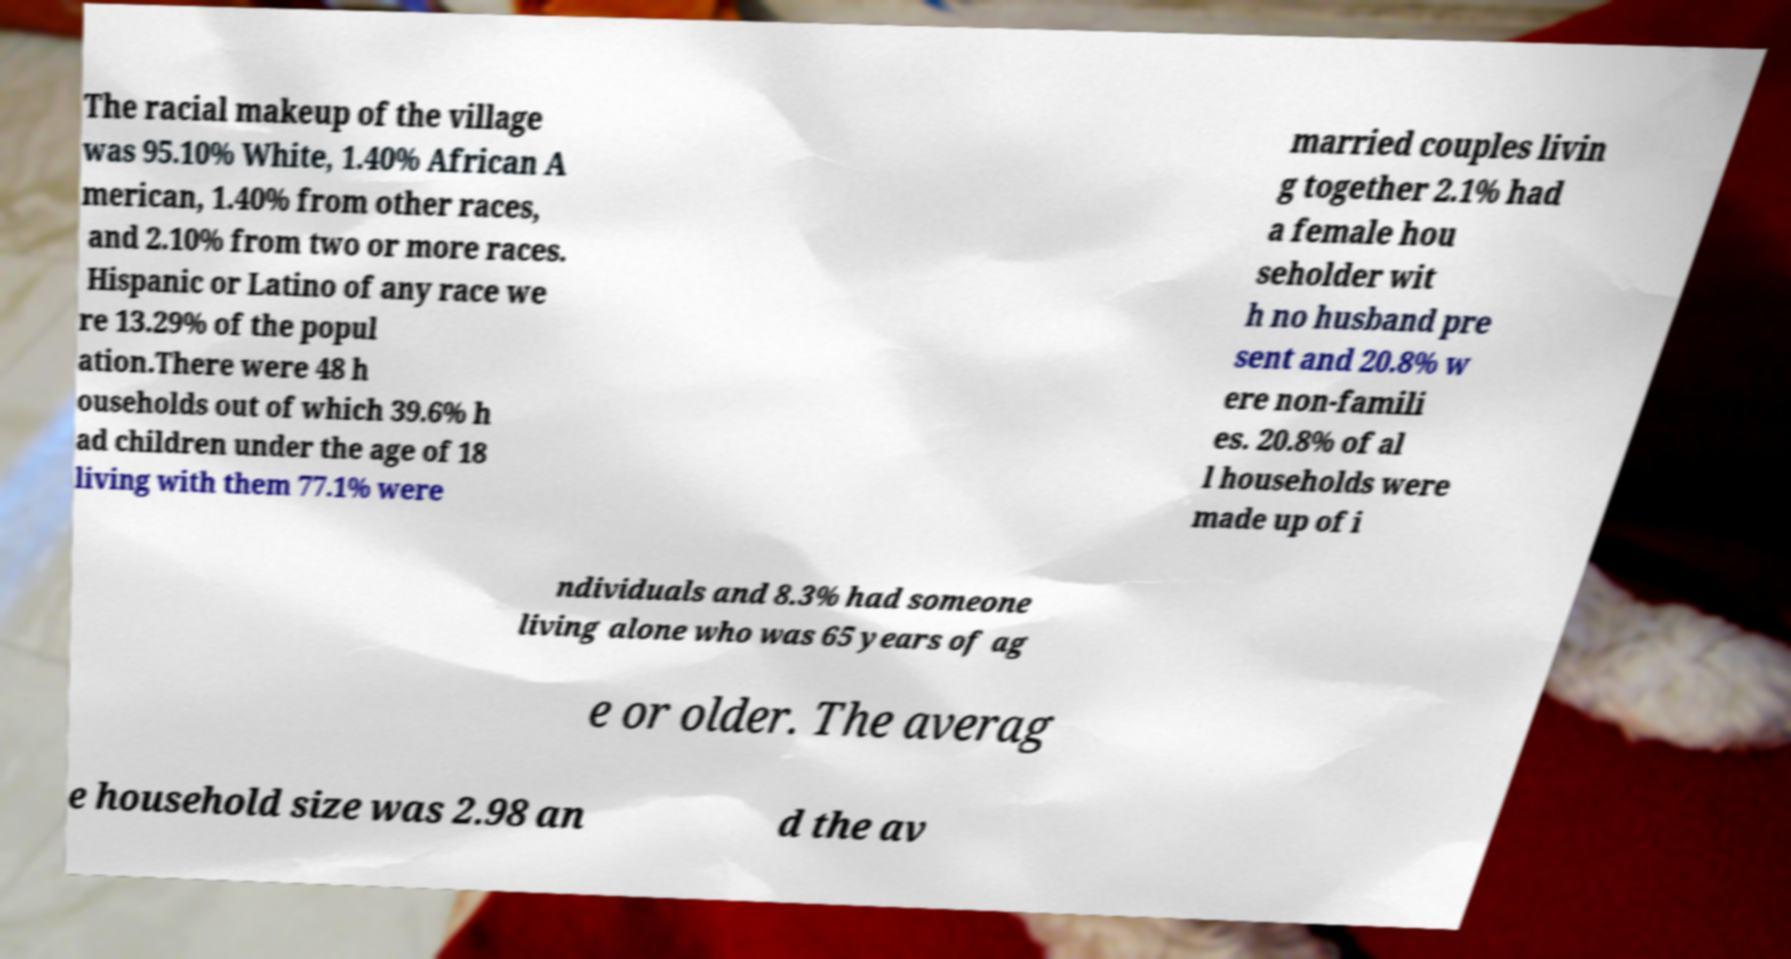I need the written content from this picture converted into text. Can you do that? The racial makeup of the village was 95.10% White, 1.40% African A merican, 1.40% from other races, and 2.10% from two or more races. Hispanic or Latino of any race we re 13.29% of the popul ation.There were 48 h ouseholds out of which 39.6% h ad children under the age of 18 living with them 77.1% were married couples livin g together 2.1% had a female hou seholder wit h no husband pre sent and 20.8% w ere non-famili es. 20.8% of al l households were made up of i ndividuals and 8.3% had someone living alone who was 65 years of ag e or older. The averag e household size was 2.98 an d the av 